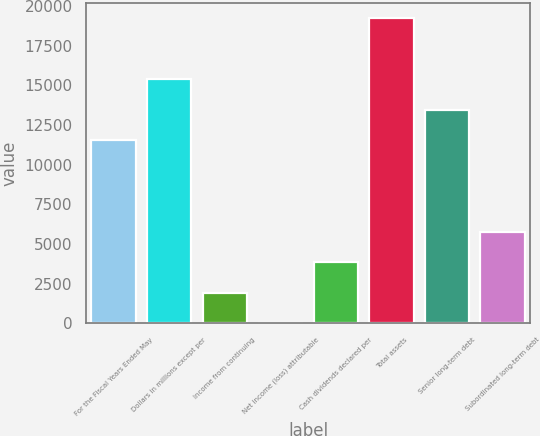Convert chart. <chart><loc_0><loc_0><loc_500><loc_500><bar_chart><fcel>For the Fiscal Years Ended May<fcel>Dollars in millions except per<fcel>Income from continuing<fcel>Net income (loss) attributable<fcel>Cash dividends declared per<fcel>Total assets<fcel>Senior long-term debt<fcel>Subordinated long-term debt<nl><fcel>11545.2<fcel>15393.4<fcel>1924.8<fcel>0.72<fcel>3848.88<fcel>19241.5<fcel>13469.3<fcel>5772.96<nl></chart> 